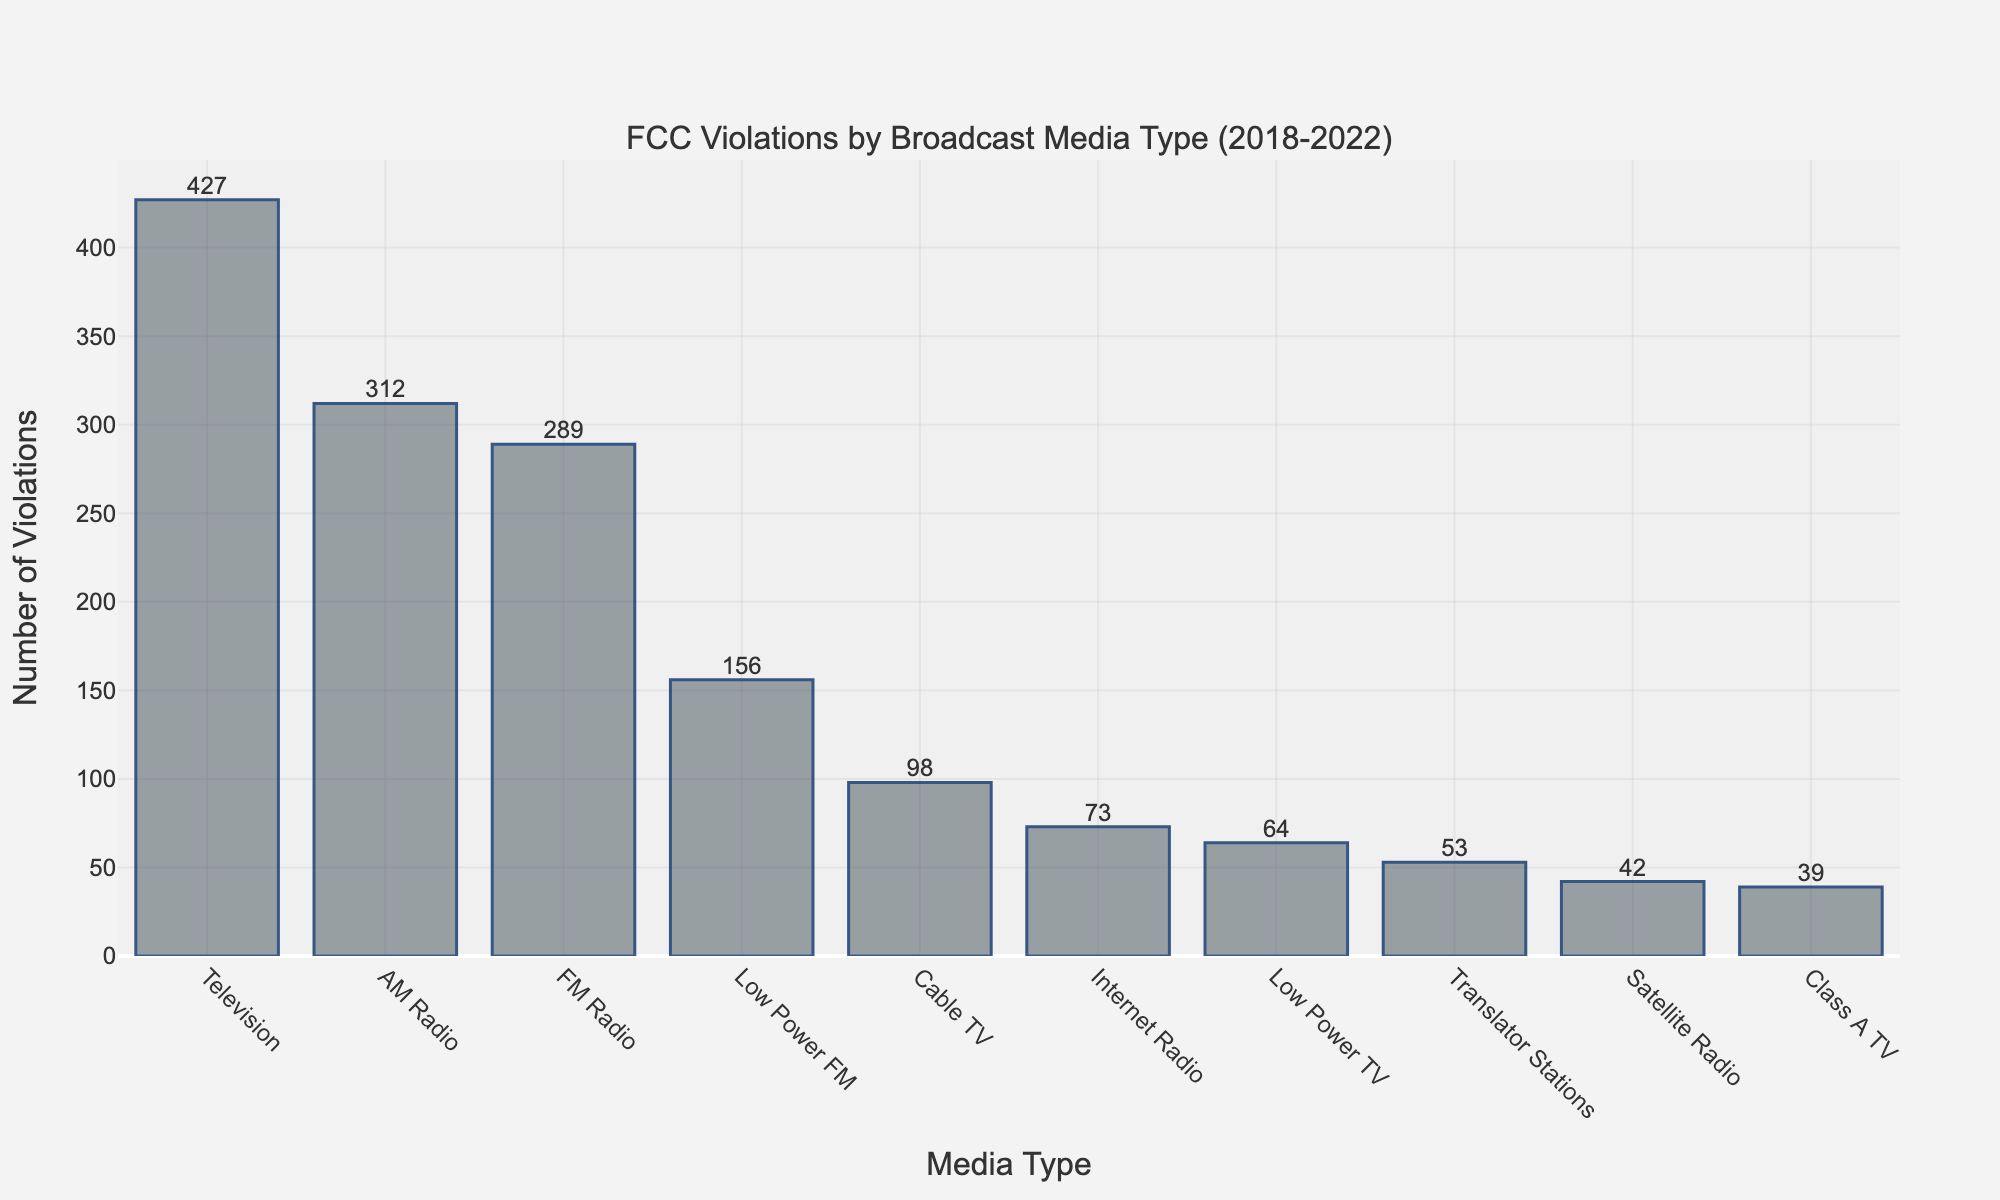What's the media type with the highest number of violations? The media type with the highest number of violations can be identified by finding the tallest bar in the bar chart. The bar representing "Television" is the tallest, indicating it has the highest number of violations.
Answer: Television Which media type has fewer violations, AM Radio or FM Radio? To determine which media type has fewer violations, compare the height of the bars for "AM Radio" and "FM Radio". The bar for "FM Radio" is slightly lower than that for "AM Radio", indicating that "FM Radio" has fewer violations.
Answer: FM Radio What's the total number of violations for Cable TV, Internet Radio, and Low Power TV combined? Calculate the total by summing the number of violations for Cable TV (98), Internet Radio (73), and Low Power TV (64): 98 + 73 + 64 = 235.
Answer: 235 Which two media types have the closest number of violations? To find the media types with the closest number of violations, compare the heights of each pair of adjacent bars. "Cable TV" and "Internet Radio" appear close, but "Translator Stations" and "Class A TV" are closest with 53 and 39 violations, respectively, making a difference of 14.
Answer: Translator Stations and Class A TV How much more frequent are violations in Television compared to Satellite Radio? Subtract the number of violations of Satellite Radio (42) from that of Television (427): 427 - 42 = 385. Violations are 385 more frequent in Television compared to Satellite Radio.
Answer: 385 more What's the average number of violations across all media types? Sum the violations for all media types (427 + 312 + 289 + 156 + 42 + 98 + 73 + 64 + 53 + 39 = 1553) and divide by the number of media types (10): 1553 / 10 = 155.3.
Answer: 155.3 By how much does the number of violations for Low Power FM exceed that of Low Power TV? Subtract the number of violations of Low Power TV (64) from that of Low Power FM (156): 156 - 64 = 92.
Answer: 92 Which has more violations, the combined total of FM Radio and AM Radio or the sum of violations for all other media types? First, sum the violations for FM Radio and AM Radio: 289 + 312 = 601. Then, sum the violations for all other media types (427 + 156 + 42 + 98 + 73 + 64 + 53 + 39 = 952). 952 is greater than 601.
Answer: All other media types What is the difference in the number of violations between the most and least violated media types? Identify the most and least violated media types. Most: Television (427). Least: Class A TV (39). Find the difference: 427 - 39 = 388.
Answer: 388 If the violations for Translator Stations increased by 50%, how many violations would that be? Calculate the 50% increase in the number of violations for Translator Stations: 53 * 0.5 = 26.5. Add this to the original number: 53 + 26.5 = 79.5.
Answer: 79.5 